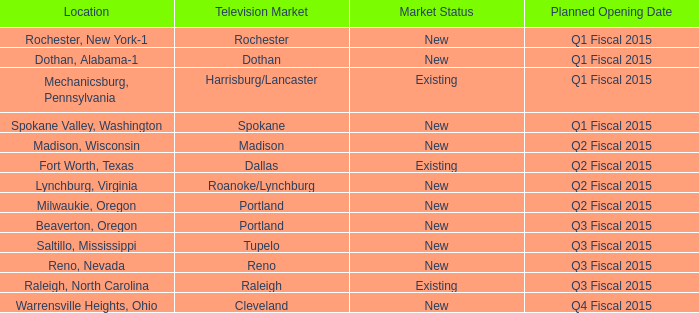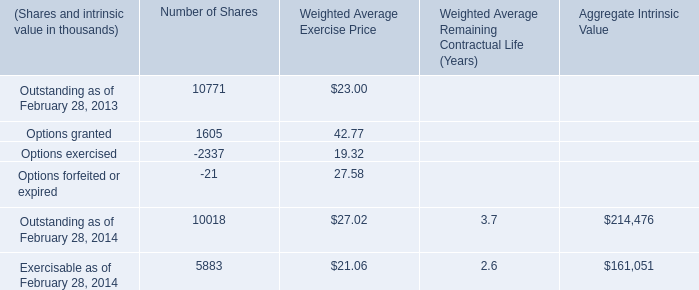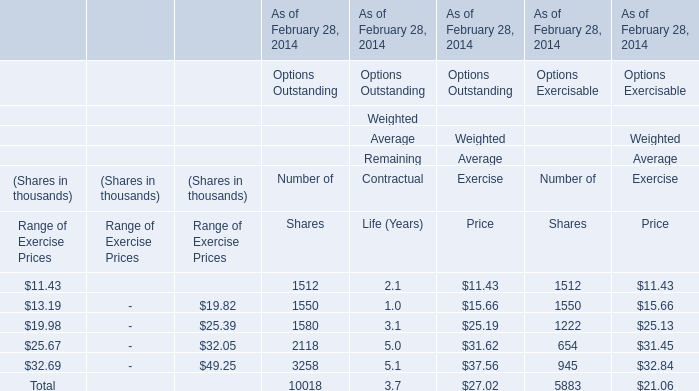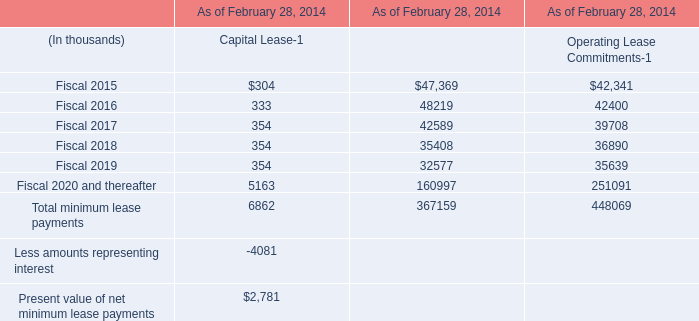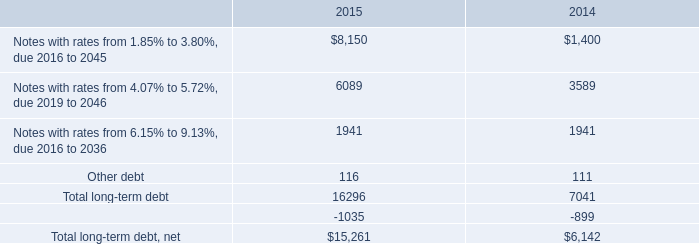in november 2015 what was the percent of the discounts and debt issuance costs to the long-term debt november 2015 notes in millions 
Computations: ((7 - 6.9) / 7.0)
Answer: 0.01429. 